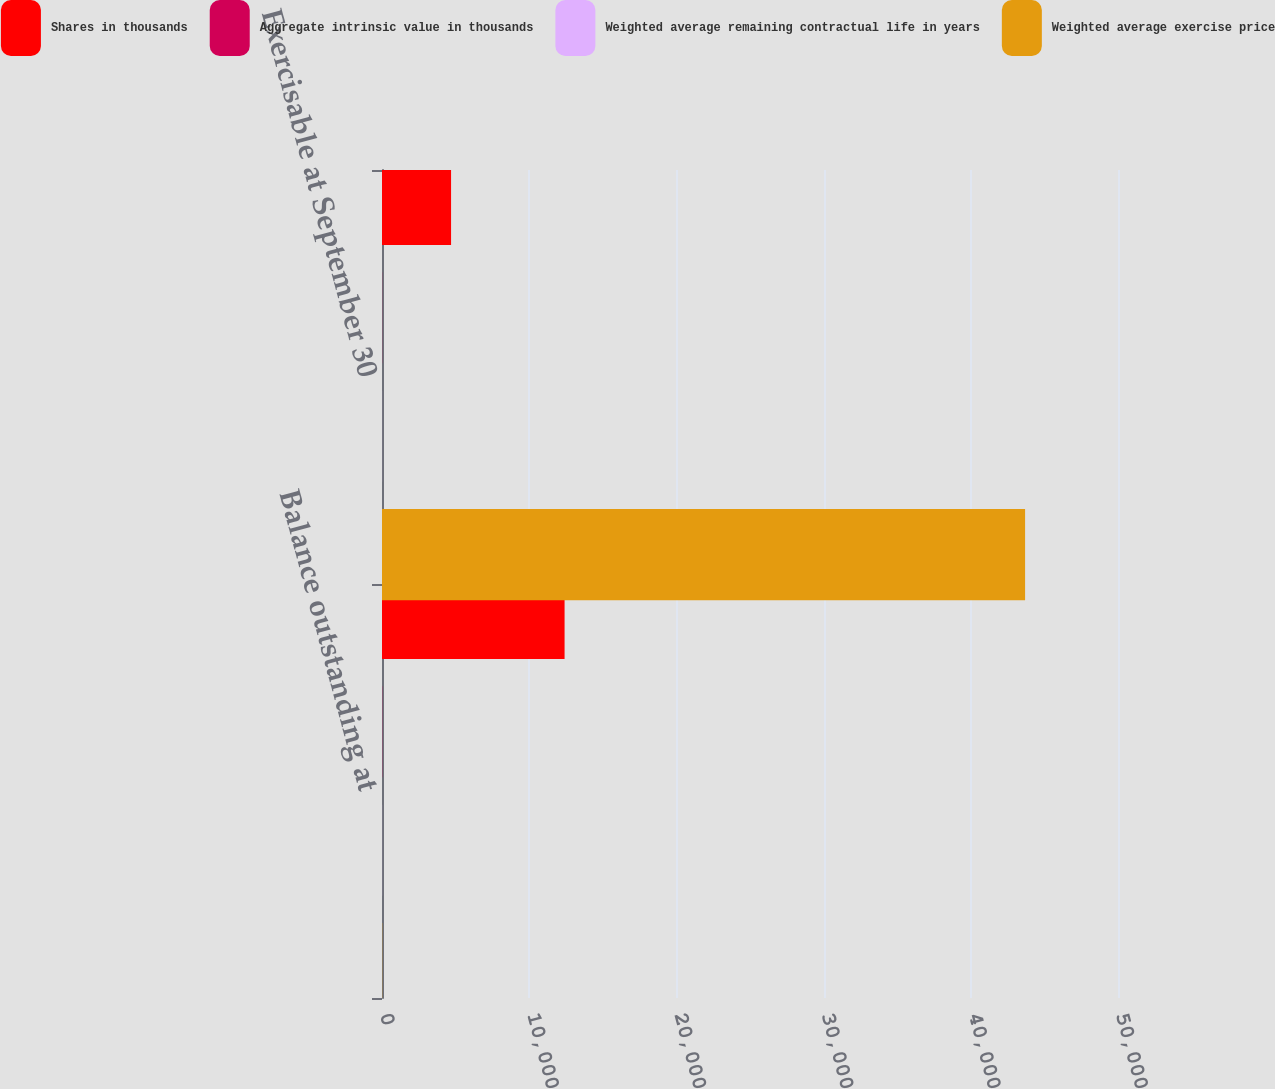<chart> <loc_0><loc_0><loc_500><loc_500><stacked_bar_chart><ecel><fcel>Balance outstanding at<fcel>Exercisable at September 30<nl><fcel>Shares in thousands<fcel>12403<fcel>4692<nl><fcel>Aggregate intrinsic value in thousands<fcel>13.45<fcel>8.72<nl><fcel>Weighted average remaining contractual life in years<fcel>5<fcel>3.9<nl><fcel>Weighted average exercise price<fcel>13.45<fcel>43688<nl></chart> 